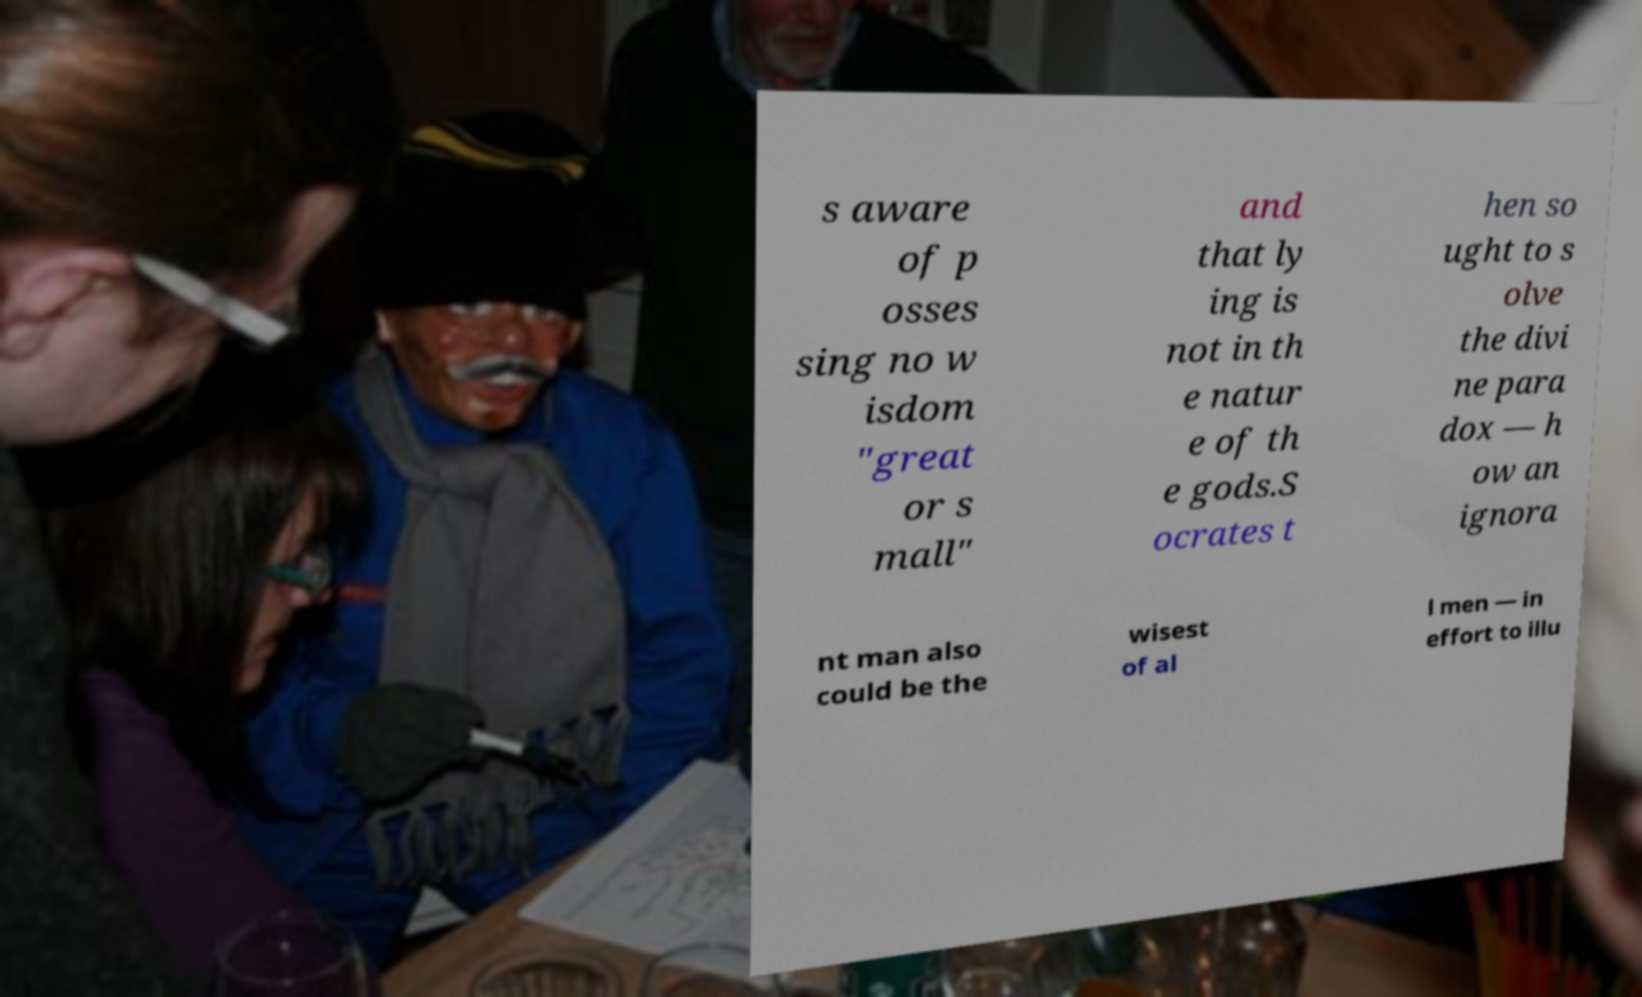Please read and relay the text visible in this image. What does it say? s aware of p osses sing no w isdom "great or s mall" and that ly ing is not in th e natur e of th e gods.S ocrates t hen so ught to s olve the divi ne para dox — h ow an ignora nt man also could be the wisest of al l men — in effort to illu 